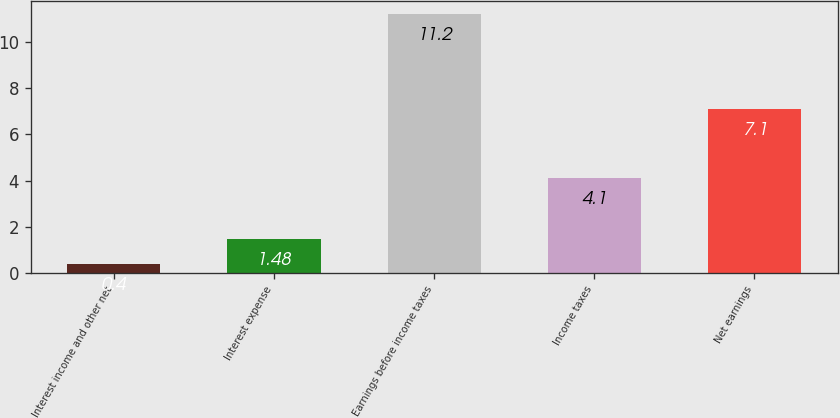<chart> <loc_0><loc_0><loc_500><loc_500><bar_chart><fcel>Interest income and other net<fcel>Interest expense<fcel>Earnings before income taxes<fcel>Income taxes<fcel>Net earnings<nl><fcel>0.4<fcel>1.48<fcel>11.2<fcel>4.1<fcel>7.1<nl></chart> 